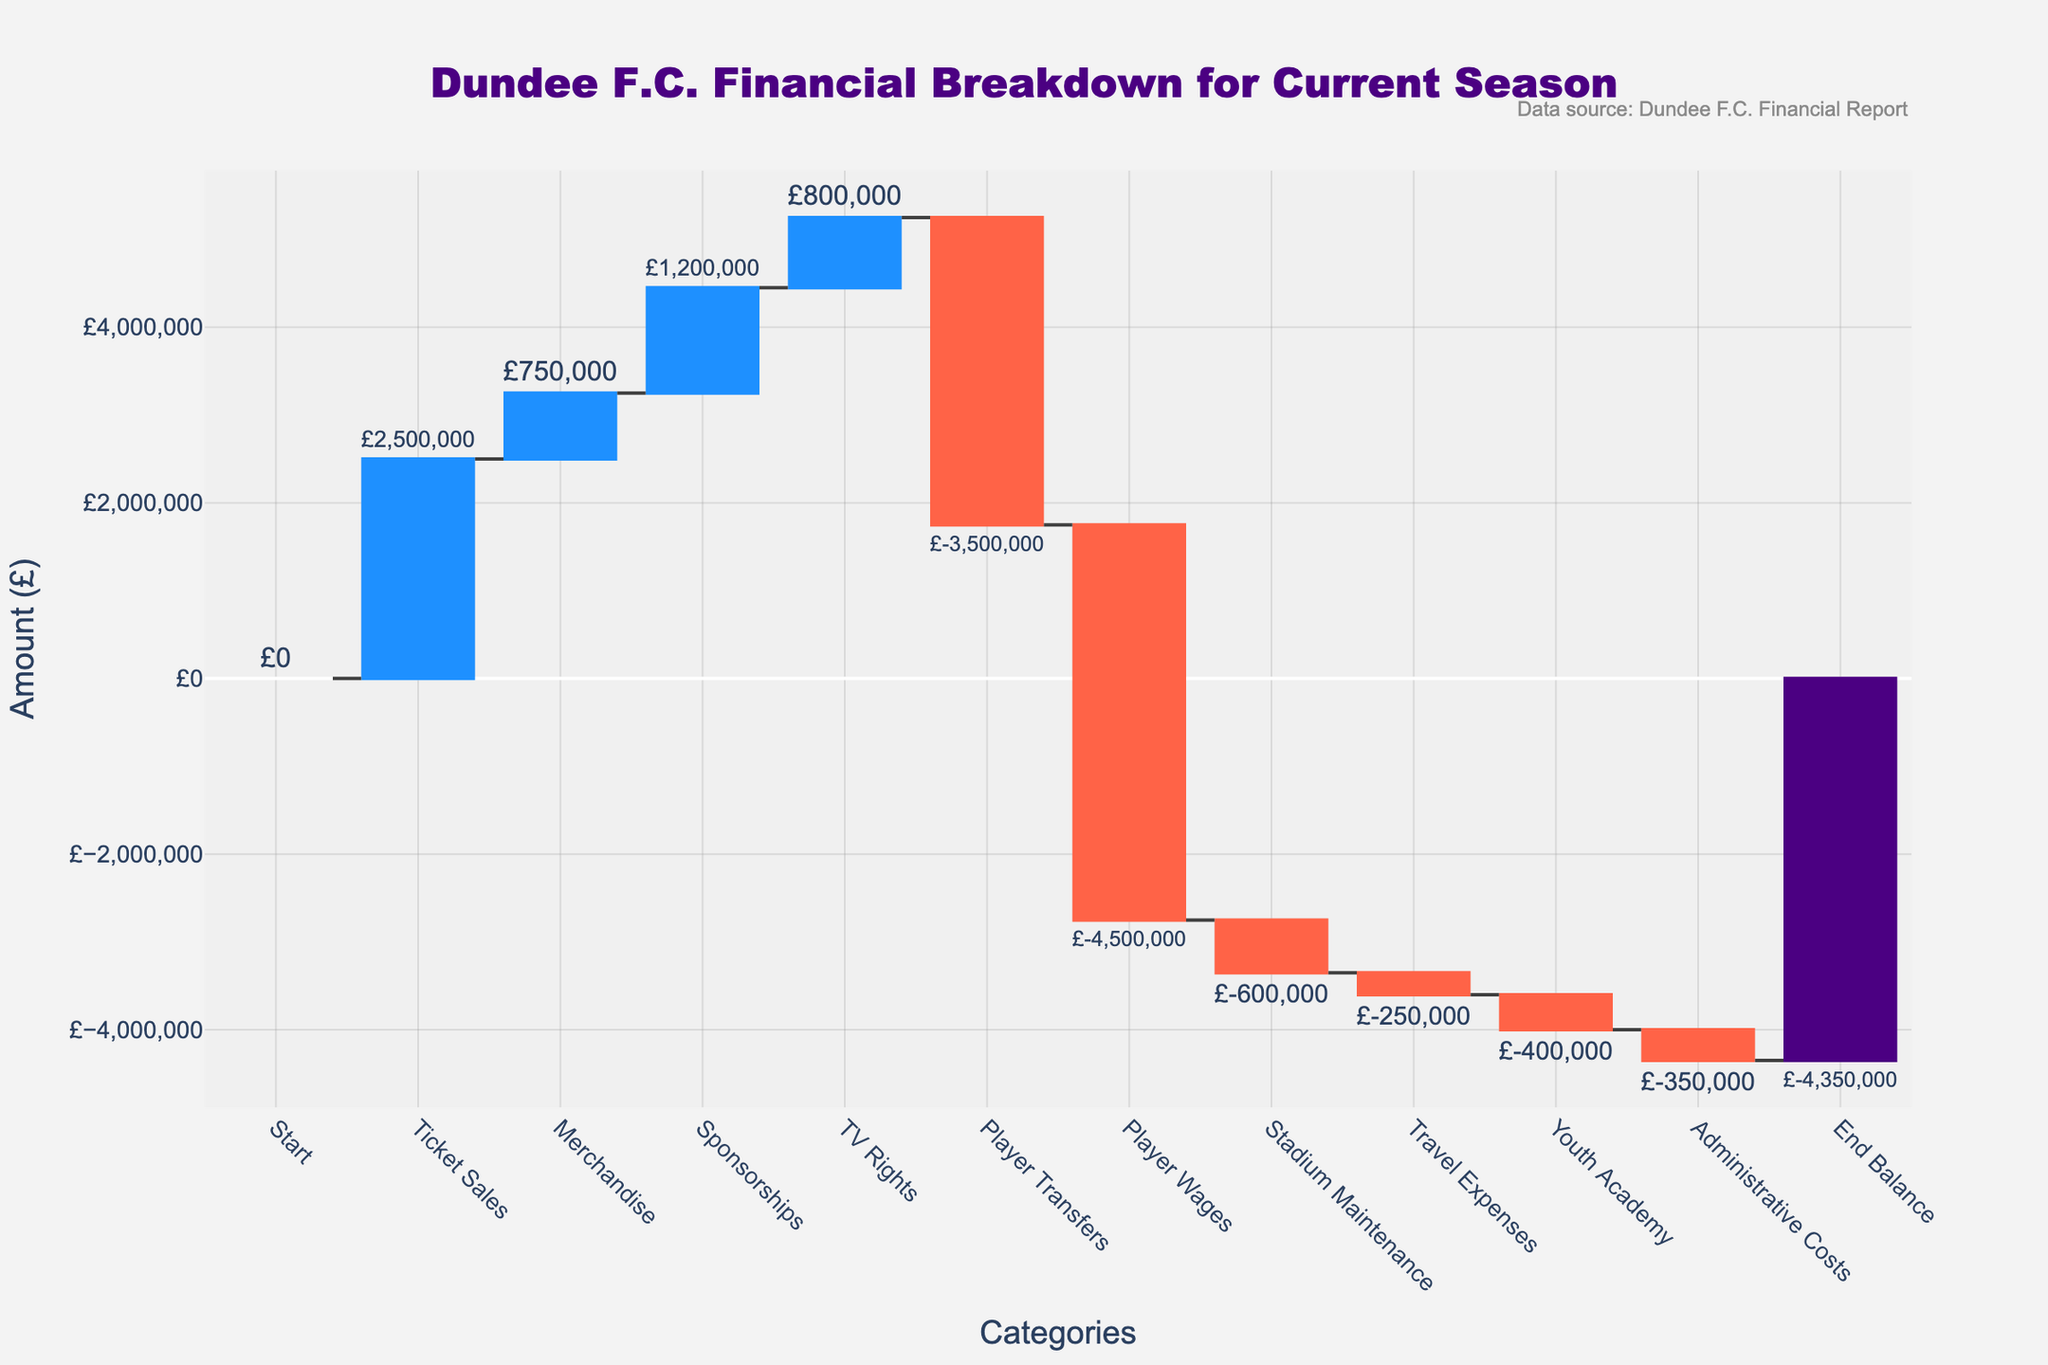What is the title of the chart? The title of the chart is usually located at the top. It reads "Dundee F.C. Financial Breakdown for Current Season."
Answer: Dundee F.C. Financial Breakdown for Current Season What is the total income from ticket sales and merchandise? Add the amounts from "Ticket Sales" and "Merchandise." Ticket Sales is £2,500,000 and Merchandise is £750,000. So, £2,500,000 + £750,000 = £3,250,000.
Answer: £3,250,000 Which category has the largest expense? Look at the negative values in the chart. "Player Wages" has the largest expense of -£4,500,000.
Answer: Player Wages How much difference is there between the total income and total expenses? Sum all the positive values for total income: £2,500,000 + £750,000 + £1,200,000 + £800,000 = £5,250,000. Sum all the negative values for total expenses: -£3,500,000 - £4,500,000 - £600,000 - £250,000 - £400,000 - £350,000 = -£9,600,000. Difference = £5,250,000 - £9,600,000 = -£4,350,000.
Answer: -£4,350,000 Which income category contributes the least and by how much? Among the positive values, "TV Rights" is the lowest at £800,000.
Answer: TV Rights with £800,000 Do sponsorships contribute more than merchandise sales? Compare the amounts for "Sponsorships" (£1,200,000) and "Merchandise" (£750,000). Sponsorships is greater.
Answer: Yes What is the end balance for the current season? The end balance is given directly in the chart under "End Balance." It is -£4,350,000.
Answer: -£4,350,000 Which has a higher cost: Stadium Maintenance or Youth Academy? Compare the values for "Stadium Maintenance" and "Youth Academy." Stadium Maintenance is -£600,000, and Youth Academy is -£400,000. Stadium Maintenance has a higher cost.
Answer: Stadium Maintenance What is the net impact of player-related activities? Combine the values for "Player Transfers" and "Player Wages." Player Transfers is -£3,500,000, and Player Wages is -£4,500,000. Net impact = -£3,500,000 - £4,500,000 = -£8,000,000.
Answer: -£8,000,000 How much more are the administrative costs compared to travel expenses? Subtract the amount for "Travel Expenses" from "Administrative Costs." Administrative Costs is -£350,000, Travel Expenses is -£250,000. Difference = -£350,000 - (-£250,000) = -£100,000.
Answer: £100,000 